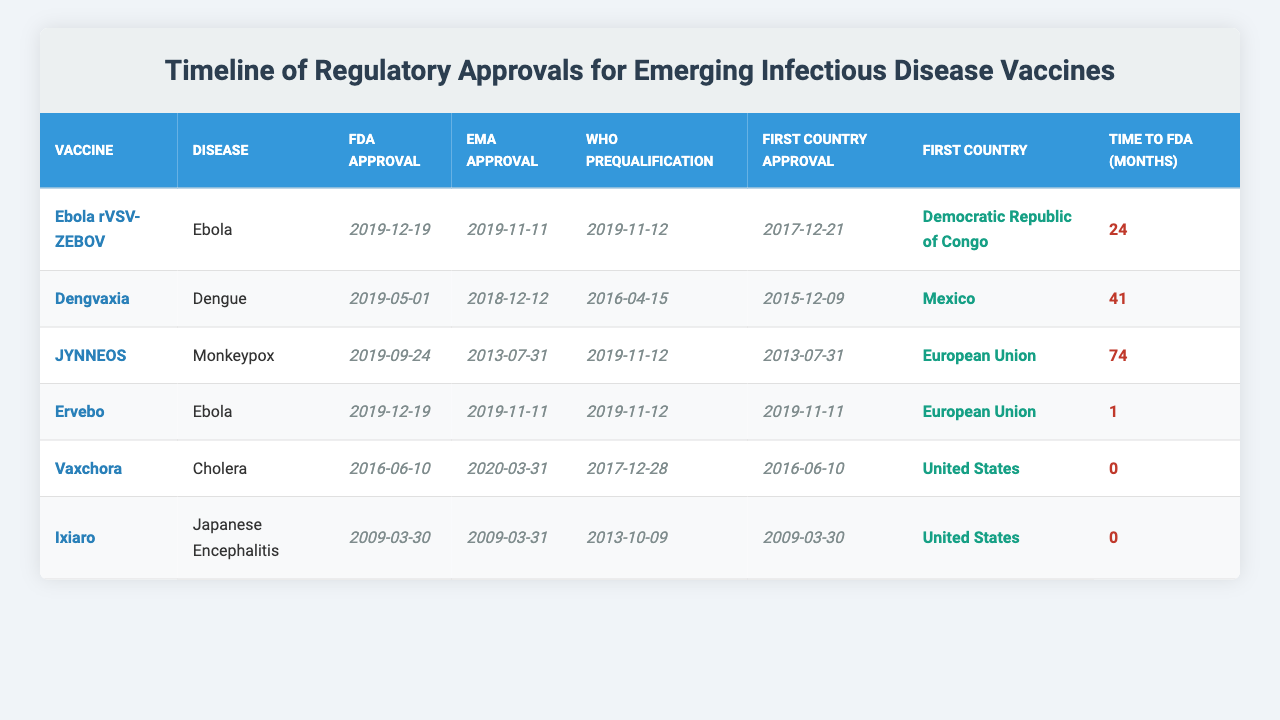What is the FDA approval date for Dengvaxia? The FDA approval date for Dengvaxia is provided directly in the table as "2019-05-01."
Answer: 2019-05-01 Which vaccine received the first country approval in the United States? The table shows two vaccines with first country approvals in the United States: Vaxchora and Ixiaro, both on "2016-06-10" and "2009-03-30" respectively. Among these, Ixiaro was approved first.
Answer: Ixiaro What is the time from the first approval to FDA approval for the JYNNEOS vaccine? For the JYNNEOS vaccine, the time from first approval to FDA approval is specified in the table as "74 months."
Answer: 74 months Which vaccine has the shortest time from first country approval to FDA approval? By examining the time listed for each vaccine, Ervebo has the shortest duration of "1 month" from its first country approval on "2019-11-11" to FDA approval on "2019-12-19."
Answer: Ervebo How many vaccines received FDA approval after 2019? By scanning the table for FDA approval dates, only 1 vaccine (Dengvaxia) received FDA approval in 2019.
Answer: 1 What is the average time from first approval to FDA approval for the vaccines listed? To find the average, add the times (24 + 41 + 74 + 1 + 0 + 0) = 140 months, then divide by 6 (the number of vaccines), resulting in an average of approximately 23.3 months.
Answer: 23.3 months Which vaccine had the earliest first country approval date, and what was that date? The earliest first country approval is for Ixiaro on "2009-03-30," which can be found in the table by identifying the minimum date listed.
Answer: 2009-03-30 Is there any vaccine that received WHO prequalification before its EMA approval date? By checking the table, yes, Dengvaxia received WHO prequalification on "2016-04-15," while its EMA approval was on "2018-12-12," indicating it was prequalified in advance.
Answer: Yes Which vaccine had the longest time from its first approval to FDA approval, and what is that duration? Upon reviewing the times listed in the table, JYNNEOS has the longest duration of "74 months" from first approval to FDA approval.
Answer: JYNNEOS, 74 months Did any vaccine obtain first country approval prior to receiving WHO prequalification? By examining the table, it's clear that all vaccines listed had their first country approvals before or on the same date as their WHO prequalification dates.
Answer: Yes 